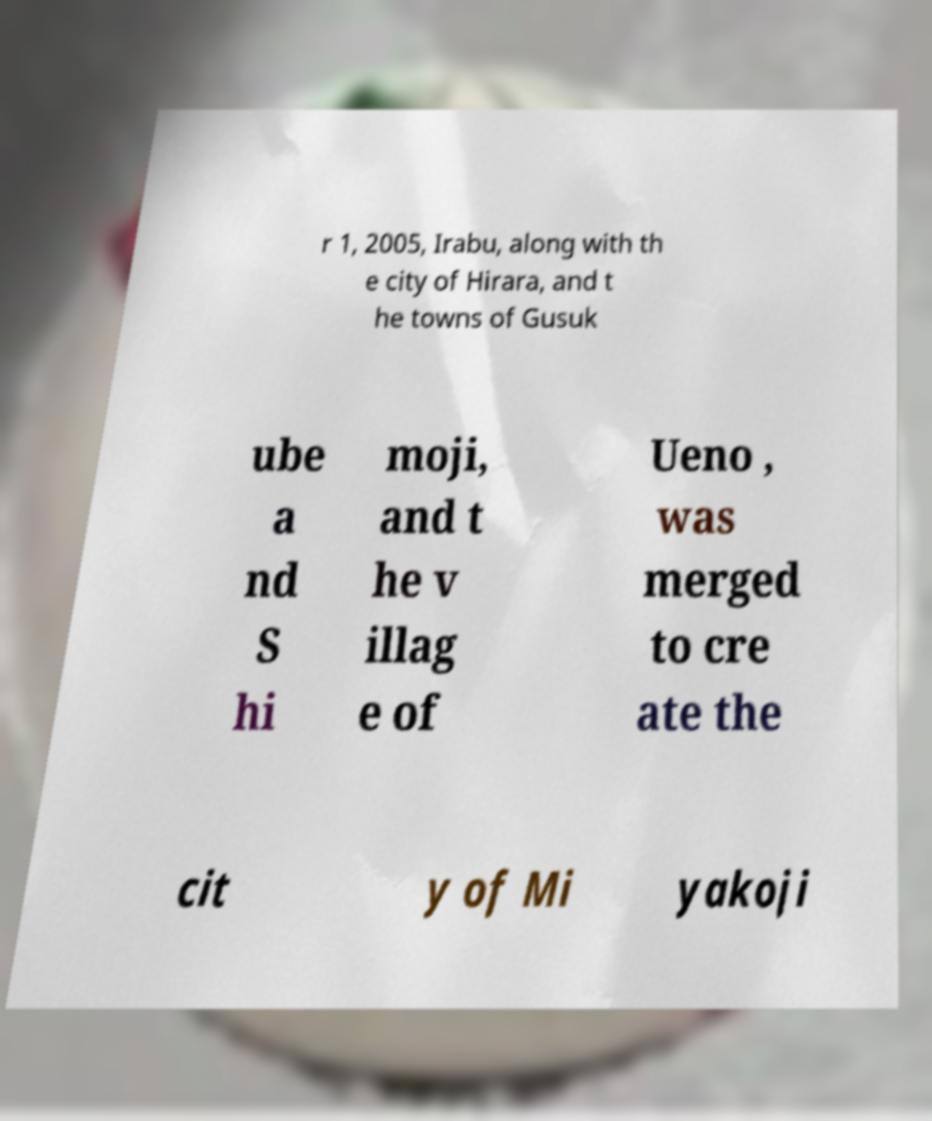Could you extract and type out the text from this image? r 1, 2005, Irabu, along with th e city of Hirara, and t he towns of Gusuk ube a nd S hi moji, and t he v illag e of Ueno , was merged to cre ate the cit y of Mi yakoji 